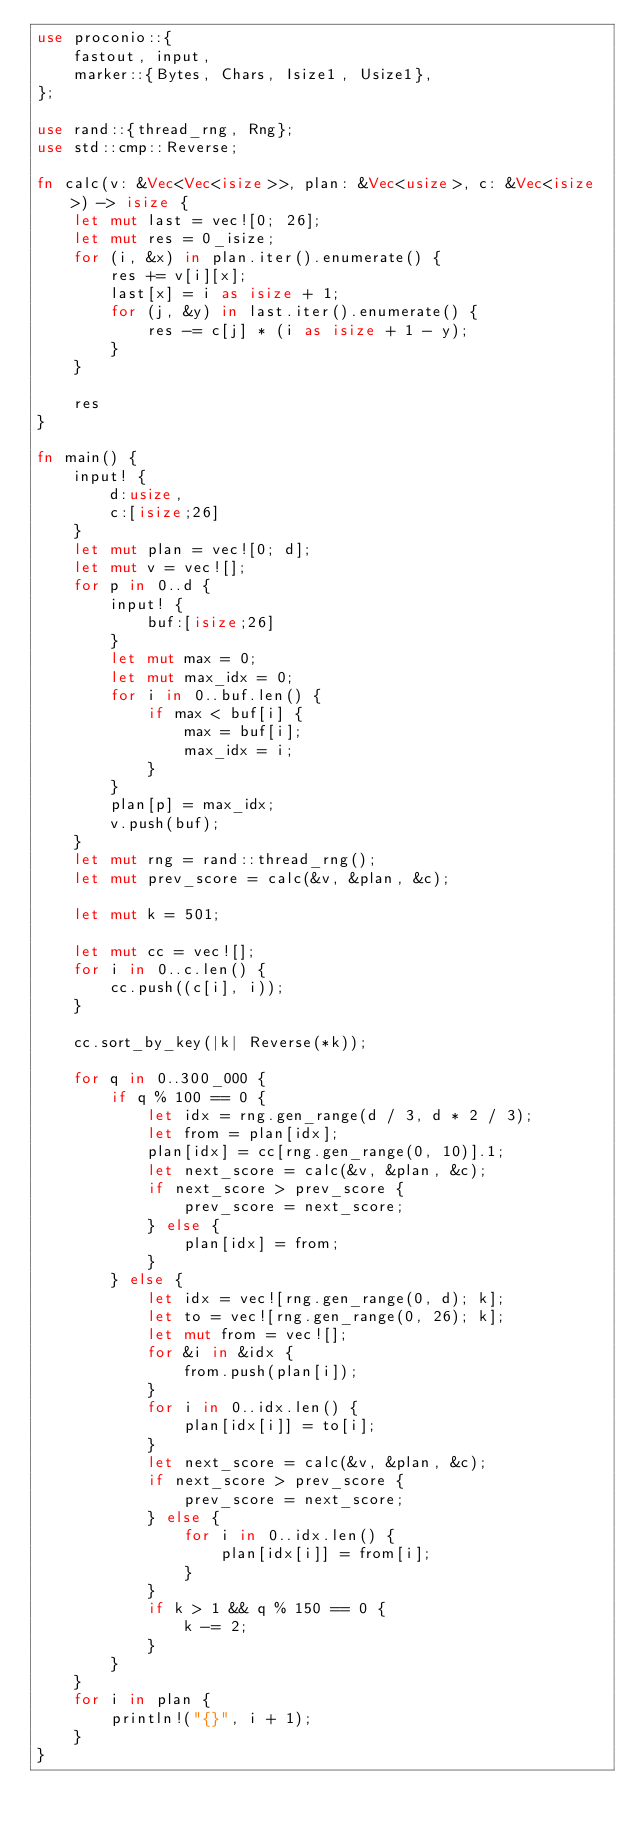<code> <loc_0><loc_0><loc_500><loc_500><_Rust_>use proconio::{
    fastout, input,
    marker::{Bytes, Chars, Isize1, Usize1},
};

use rand::{thread_rng, Rng};
use std::cmp::Reverse;

fn calc(v: &Vec<Vec<isize>>, plan: &Vec<usize>, c: &Vec<isize>) -> isize {
    let mut last = vec![0; 26];
    let mut res = 0_isize;
    for (i, &x) in plan.iter().enumerate() {
        res += v[i][x];
        last[x] = i as isize + 1;
        for (j, &y) in last.iter().enumerate() {
            res -= c[j] * (i as isize + 1 - y);
        }
    }

    res
}

fn main() {
    input! {
        d:usize,
        c:[isize;26]
    }
    let mut plan = vec![0; d];
    let mut v = vec![];
    for p in 0..d {
        input! {
            buf:[isize;26]
        }
        let mut max = 0;
        let mut max_idx = 0;
        for i in 0..buf.len() {
            if max < buf[i] {
                max = buf[i];
                max_idx = i;
            }
        }
        plan[p] = max_idx;
        v.push(buf);
    }
    let mut rng = rand::thread_rng();
    let mut prev_score = calc(&v, &plan, &c);

    let mut k = 501;

    let mut cc = vec![];
    for i in 0..c.len() {
        cc.push((c[i], i));
    }

    cc.sort_by_key(|k| Reverse(*k));

    for q in 0..300_000 {
        if q % 100 == 0 {
            let idx = rng.gen_range(d / 3, d * 2 / 3);
            let from = plan[idx];
            plan[idx] = cc[rng.gen_range(0, 10)].1;
            let next_score = calc(&v, &plan, &c);
            if next_score > prev_score {
                prev_score = next_score;
            } else {
                plan[idx] = from;
            }
        } else {
            let idx = vec![rng.gen_range(0, d); k];
            let to = vec![rng.gen_range(0, 26); k];
            let mut from = vec![];
            for &i in &idx {
                from.push(plan[i]);
            }
            for i in 0..idx.len() {
                plan[idx[i]] = to[i];
            }
            let next_score = calc(&v, &plan, &c);
            if next_score > prev_score {
                prev_score = next_score;
            } else {
                for i in 0..idx.len() {
                    plan[idx[i]] = from[i];
                }
            }
            if k > 1 && q % 150 == 0 {
                k -= 2;
            }
        }
    }
    for i in plan {
        println!("{}", i + 1);
    }
}
</code> 